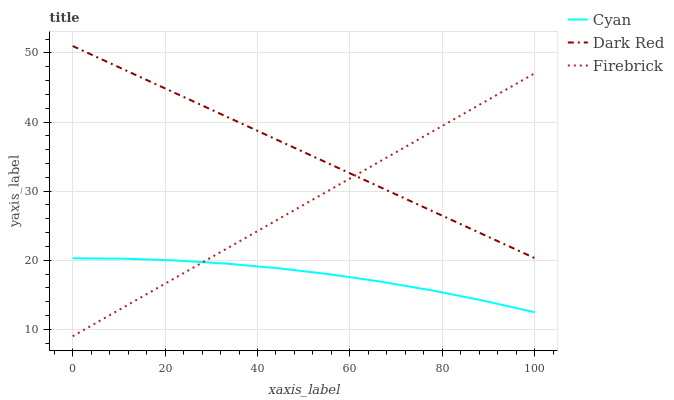Does Firebrick have the minimum area under the curve?
Answer yes or no. No. Does Firebrick have the maximum area under the curve?
Answer yes or no. No. Is Dark Red the smoothest?
Answer yes or no. No. Is Dark Red the roughest?
Answer yes or no. No. Does Dark Red have the lowest value?
Answer yes or no. No. Does Firebrick have the highest value?
Answer yes or no. No. Is Cyan less than Dark Red?
Answer yes or no. Yes. Is Dark Red greater than Cyan?
Answer yes or no. Yes. Does Cyan intersect Dark Red?
Answer yes or no. No. 